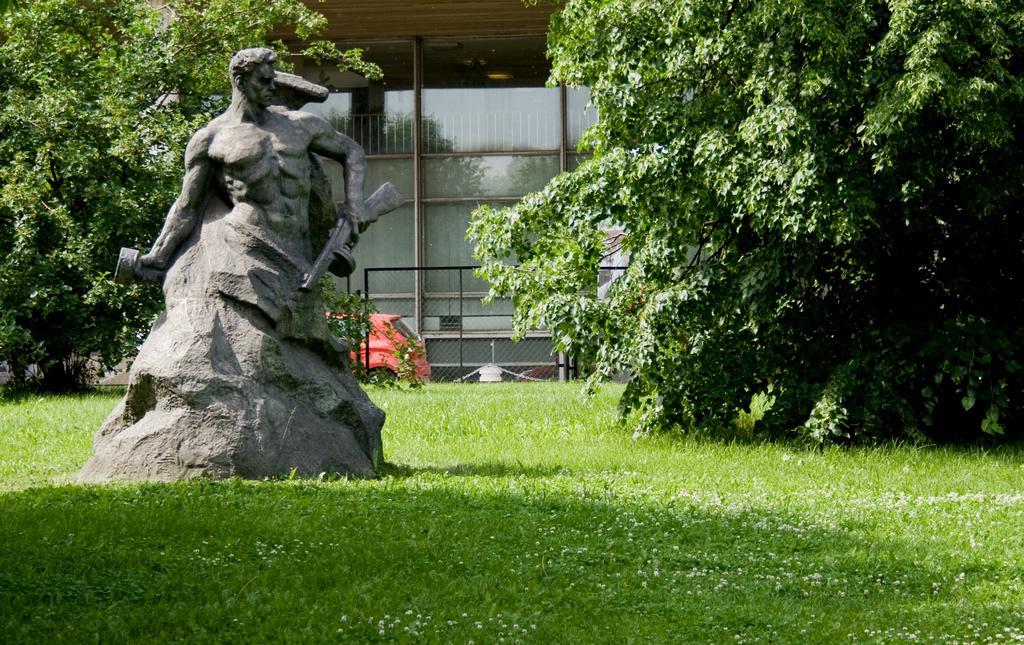Please provide a concise description of this image. As we can see in the image there are statues, grass, trees, building, fence and red color car. 